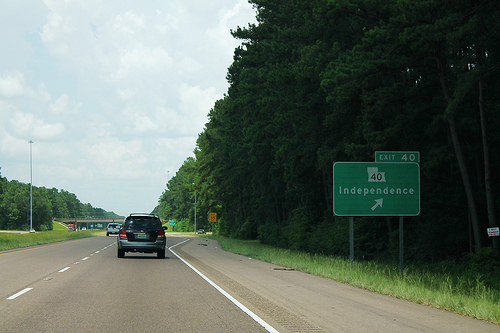<image>
Is there a car behind the street sign? Yes. From this viewpoint, the car is positioned behind the street sign, with the street sign partially or fully occluding the car. Where is the rumble strip in relation to the forest? Is it next to the forest? Yes. The rumble strip is positioned adjacent to the forest, located nearby in the same general area. Is there a car in front of the sign? Yes. The car is positioned in front of the sign, appearing closer to the camera viewpoint. 